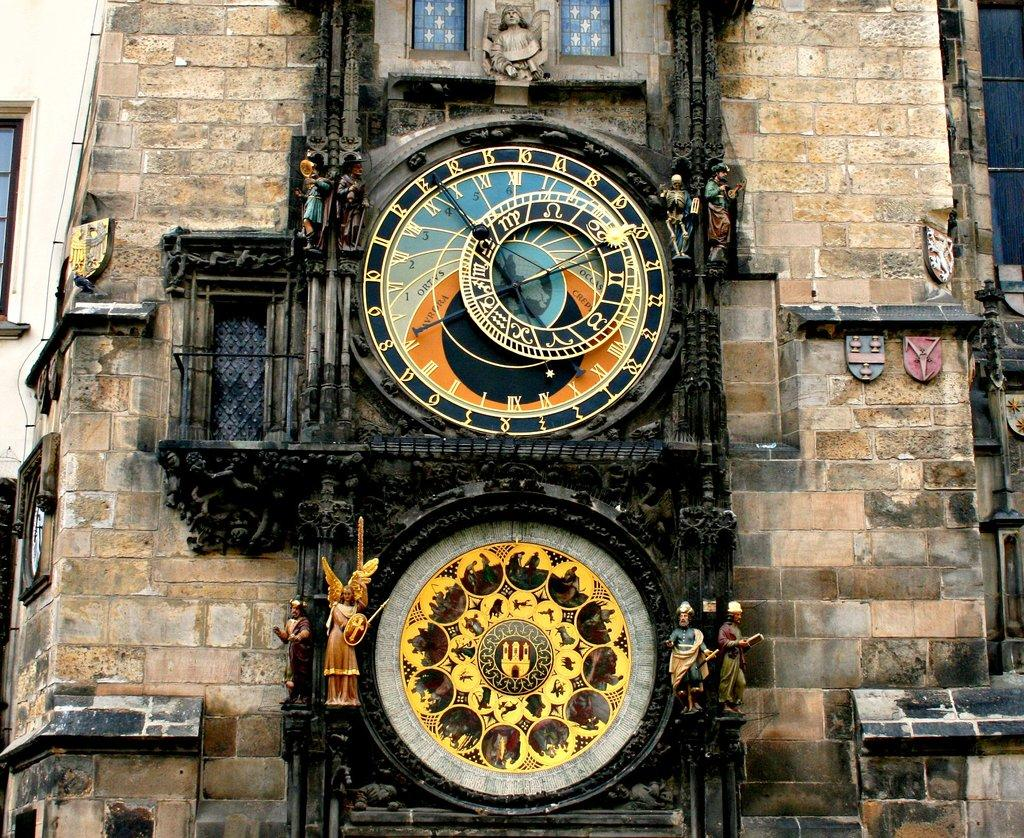What is the main subject of the image? The main subject of the image is a building. Are there any specific features on the building? Yes, there is a clock on the building. What else can be seen on the building? Depictions of humans are visible on the building. How does the body of water in the image affect the quicksand? There is no body of water or quicksand present in the image; it is a zoomed-in picture of a building with a clock and depictions of humans. 